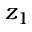Convert formula to latex. <formula><loc_0><loc_0><loc_500><loc_500>z _ { 1 }</formula> 